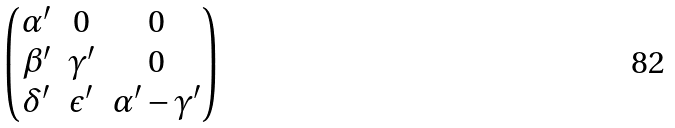Convert formula to latex. <formula><loc_0><loc_0><loc_500><loc_500>\begin{pmatrix} \alpha ^ { \prime } & 0 & 0 \\ \beta ^ { \prime } & \gamma ^ { \prime } & 0 \\ \delta ^ { \prime } & \epsilon ^ { \prime } & \alpha ^ { \prime } - \gamma ^ { \prime } \end{pmatrix}</formula> 